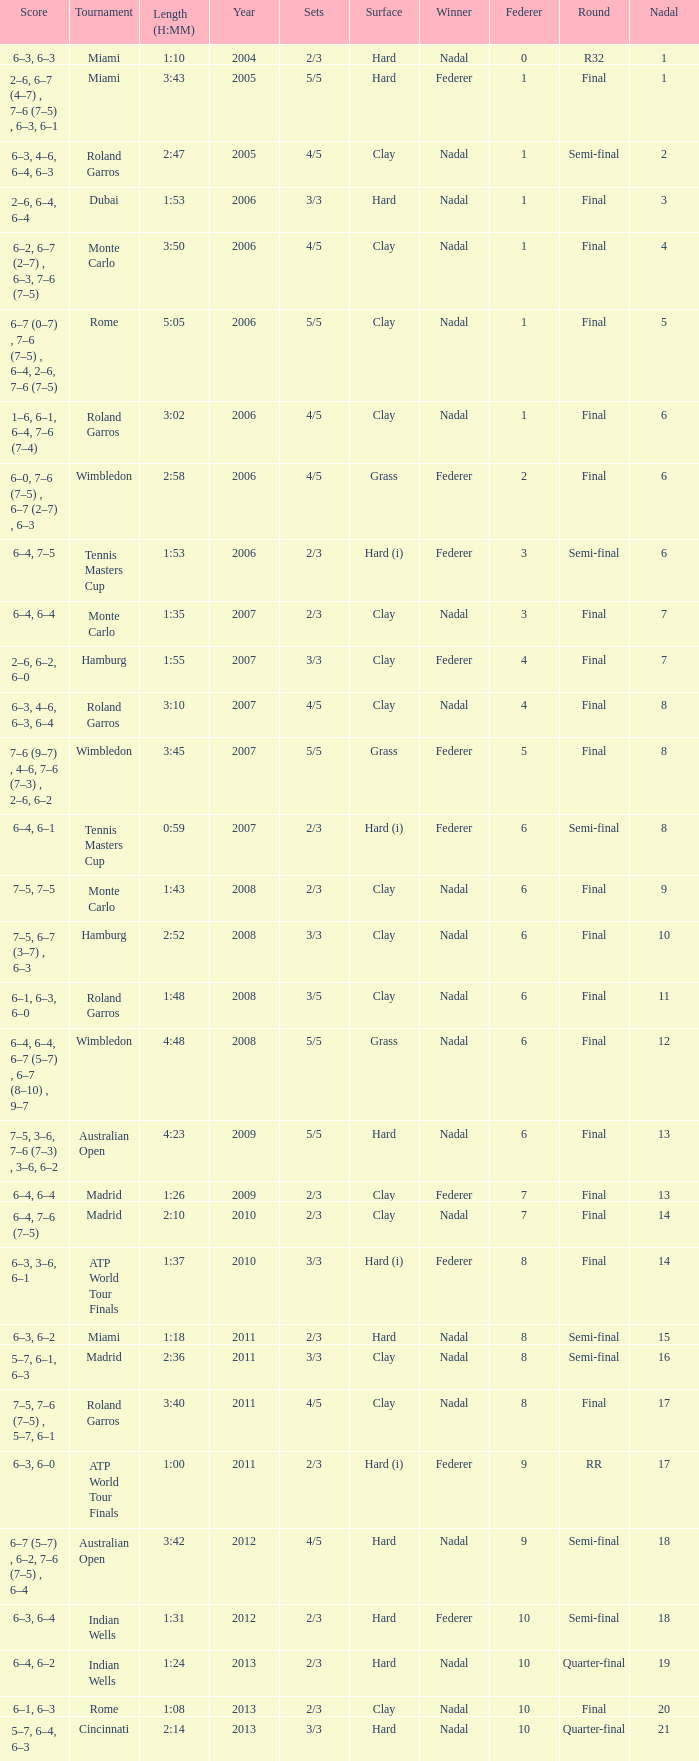What was the nadal in Miami in the final round? 1.0. Write the full table. {'header': ['Score', 'Tournament', 'Length (H:MM)', 'Year', 'Sets', 'Surface', 'Winner', 'Federer', 'Round', 'Nadal'], 'rows': [['6–3, 6–3', 'Miami', '1:10', '2004', '2/3', 'Hard', 'Nadal', '0', 'R32', '1'], ['2–6, 6–7 (4–7) , 7–6 (7–5) , 6–3, 6–1', 'Miami', '3:43', '2005', '5/5', 'Hard', 'Federer', '1', 'Final', '1'], ['6–3, 4–6, 6–4, 6–3', 'Roland Garros', '2:47', '2005', '4/5', 'Clay', 'Nadal', '1', 'Semi-final', '2'], ['2–6, 6–4, 6–4', 'Dubai', '1:53', '2006', '3/3', 'Hard', 'Nadal', '1', 'Final', '3'], ['6–2, 6–7 (2–7) , 6–3, 7–6 (7–5)', 'Monte Carlo', '3:50', '2006', '4/5', 'Clay', 'Nadal', '1', 'Final', '4'], ['6–7 (0–7) , 7–6 (7–5) , 6–4, 2–6, 7–6 (7–5)', 'Rome', '5:05', '2006', '5/5', 'Clay', 'Nadal', '1', 'Final', '5'], ['1–6, 6–1, 6–4, 7–6 (7–4)', 'Roland Garros', '3:02', '2006', '4/5', 'Clay', 'Nadal', '1', 'Final', '6'], ['6–0, 7–6 (7–5) , 6–7 (2–7) , 6–3', 'Wimbledon', '2:58', '2006', '4/5', 'Grass', 'Federer', '2', 'Final', '6'], ['6–4, 7–5', 'Tennis Masters Cup', '1:53', '2006', '2/3', 'Hard (i)', 'Federer', '3', 'Semi-final', '6'], ['6–4, 6–4', 'Monte Carlo', '1:35', '2007', '2/3', 'Clay', 'Nadal', '3', 'Final', '7'], ['2–6, 6–2, 6–0', 'Hamburg', '1:55', '2007', '3/3', 'Clay', 'Federer', '4', 'Final', '7'], ['6–3, 4–6, 6–3, 6–4', 'Roland Garros', '3:10', '2007', '4/5', 'Clay', 'Nadal', '4', 'Final', '8'], ['7–6 (9–7) , 4–6, 7–6 (7–3) , 2–6, 6–2', 'Wimbledon', '3:45', '2007', '5/5', 'Grass', 'Federer', '5', 'Final', '8'], ['6–4, 6–1', 'Tennis Masters Cup', '0:59', '2007', '2/3', 'Hard (i)', 'Federer', '6', 'Semi-final', '8'], ['7–5, 7–5', 'Monte Carlo', '1:43', '2008', '2/3', 'Clay', 'Nadal', '6', 'Final', '9'], ['7–5, 6–7 (3–7) , 6–3', 'Hamburg', '2:52', '2008', '3/3', 'Clay', 'Nadal', '6', 'Final', '10'], ['6–1, 6–3, 6–0', 'Roland Garros', '1:48', '2008', '3/5', 'Clay', 'Nadal', '6', 'Final', '11'], ['6–4, 6–4, 6–7 (5–7) , 6–7 (8–10) , 9–7', 'Wimbledon', '4:48', '2008', '5/5', 'Grass', 'Nadal', '6', 'Final', '12'], ['7–5, 3–6, 7–6 (7–3) , 3–6, 6–2', 'Australian Open', '4:23', '2009', '5/5', 'Hard', 'Nadal', '6', 'Final', '13'], ['6–4, 6–4', 'Madrid', '1:26', '2009', '2/3', 'Clay', 'Federer', '7', 'Final', '13'], ['6–4, 7–6 (7–5)', 'Madrid', '2:10', '2010', '2/3', 'Clay', 'Nadal', '7', 'Final', '14'], ['6–3, 3–6, 6–1', 'ATP World Tour Finals', '1:37', '2010', '3/3', 'Hard (i)', 'Federer', '8', 'Final', '14'], ['6–3, 6–2', 'Miami', '1:18', '2011', '2/3', 'Hard', 'Nadal', '8', 'Semi-final', '15'], ['5–7, 6–1, 6–3', 'Madrid', '2:36', '2011', '3/3', 'Clay', 'Nadal', '8', 'Semi-final', '16'], ['7–5, 7–6 (7–5) , 5–7, 6–1', 'Roland Garros', '3:40', '2011', '4/5', 'Clay', 'Nadal', '8', 'Final', '17'], ['6–3, 6–0', 'ATP World Tour Finals', '1:00', '2011', '2/3', 'Hard (i)', 'Federer', '9', 'RR', '17'], ['6–7 (5–7) , 6–2, 7–6 (7–5) , 6–4', 'Australian Open', '3:42', '2012', '4/5', 'Hard', 'Nadal', '9', 'Semi-final', '18'], ['6–3, 6–4', 'Indian Wells', '1:31', '2012', '2/3', 'Hard', 'Federer', '10', 'Semi-final', '18'], ['6–4, 6–2', 'Indian Wells', '1:24', '2013', '2/3', 'Hard', 'Nadal', '10', 'Quarter-final', '19'], ['6–1, 6–3', 'Rome', '1:08', '2013', '2/3', 'Clay', 'Nadal', '10', 'Final', '20'], ['5–7, 6–4, 6–3', 'Cincinnati', '2:14', '2013', '3/3', 'Hard', 'Nadal', '10', 'Quarter-final', '21']]} 